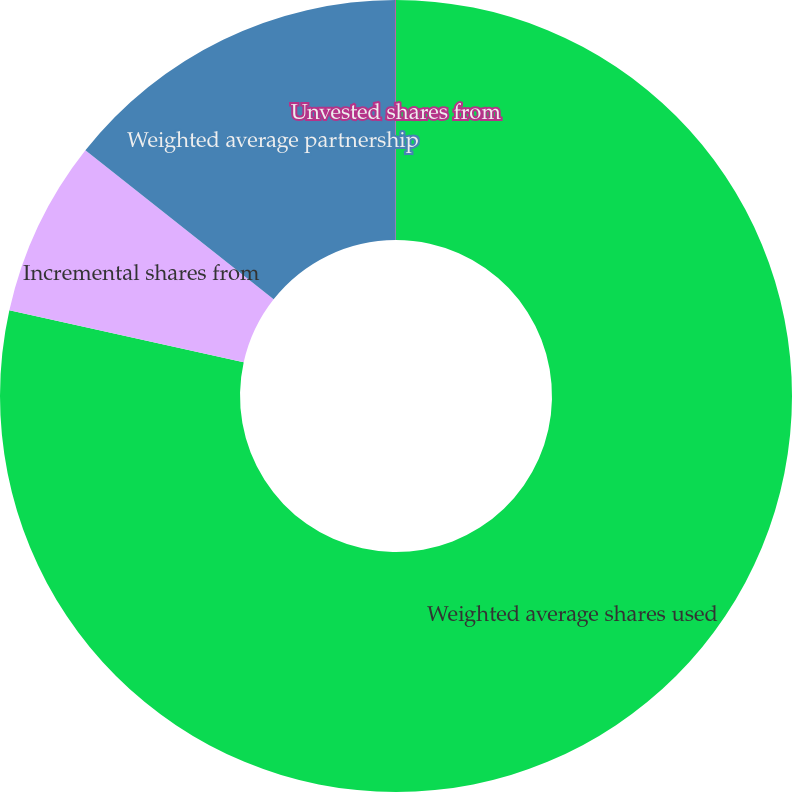Convert chart. <chart><loc_0><loc_0><loc_500><loc_500><pie_chart><fcel>Weighted average shares used<fcel>Incremental shares from<fcel>Weighted average partnership<fcel>Unvested shares from<nl><fcel>78.47%<fcel>7.18%<fcel>14.32%<fcel>0.03%<nl></chart> 